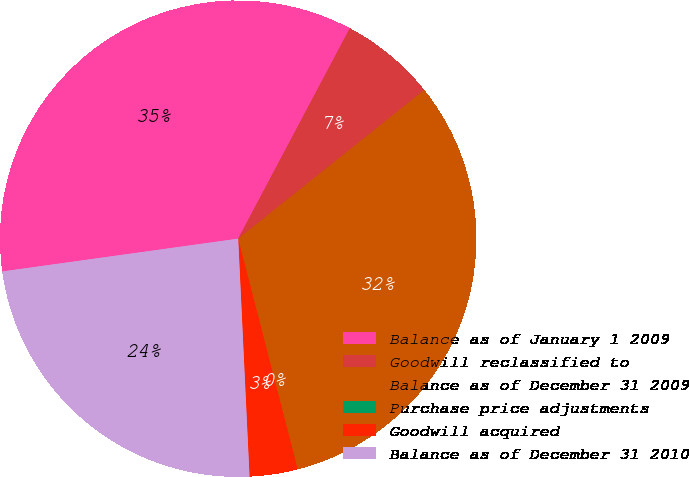<chart> <loc_0><loc_0><loc_500><loc_500><pie_chart><fcel>Balance as of January 1 2009<fcel>Goodwill reclassified to<fcel>Balance as of December 31 2009<fcel>Purchase price adjustments<fcel>Goodwill acquired<fcel>Balance as of December 31 2010<nl><fcel>34.96%<fcel>6.51%<fcel>31.71%<fcel>0.0%<fcel>3.26%<fcel>23.56%<nl></chart> 